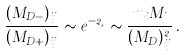Convert formula to latex. <formula><loc_0><loc_0><loc_500><loc_500>\frac { ( M _ { D - } ) _ { i j } } { ( M _ { D + } ) _ { i j } } \sim e ^ { - 2 \xi } \sim \frac { m _ { i } M _ { j } } { ( M _ { D } ) ^ { 2 } _ { i j } } \, .</formula> 